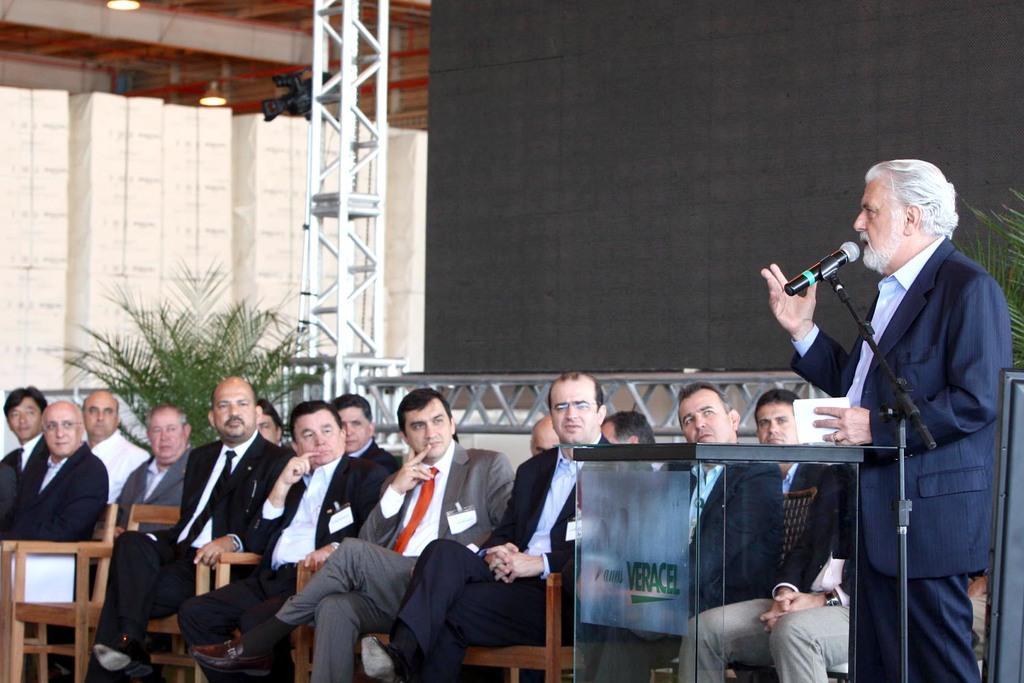Describe this image in one or two sentences. This pictures seems to be clicked inside the hall. On the right corner we can see a man wearing suit, standing and holding an object, we can see a microphone attached to the metal stand, we can see the text on the table and we can see the group of persons sitting on the wooden chairs and wearing suits. In the background we can see the green leaves, metal rods, roof, ceiling lights and some other objects. 